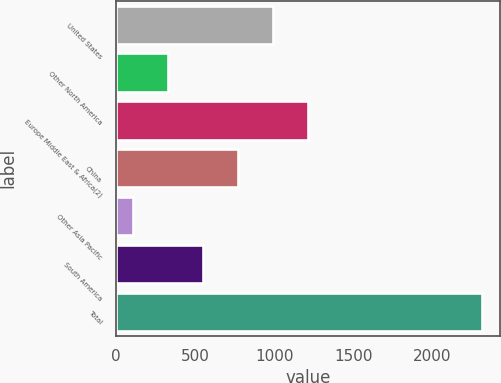<chart> <loc_0><loc_0><loc_500><loc_500><bar_chart><fcel>United States<fcel>Other North America<fcel>Europe Middle East & Africa(2)<fcel>China<fcel>Other Asia Pacific<fcel>South America<fcel>Total<nl><fcel>990.8<fcel>328.7<fcel>1211.5<fcel>770.1<fcel>108<fcel>549.4<fcel>2315<nl></chart> 